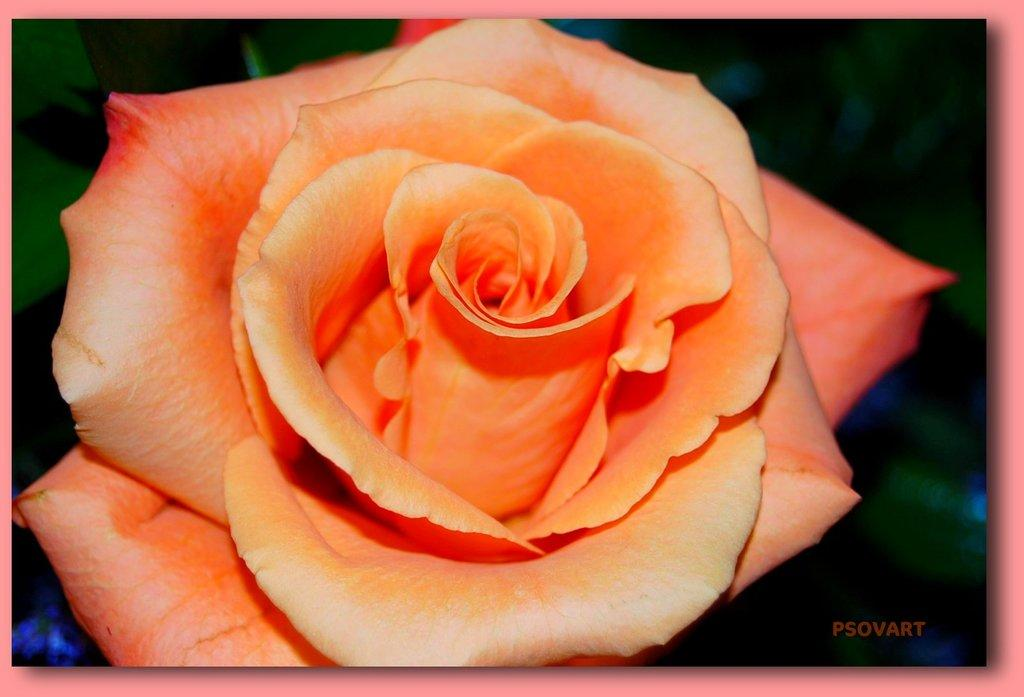What can be found in the bottom right corner of the image? A: There is a watermark in the bottom right corner of the image. What is the main subject of the image? There is a flower in the middle of the image. How would you describe the background of the image? The background of the image is blurred. How many bikes are parked next to the flower in the image? There are no bikes present in the image; it only features a flower and a blurred background. 